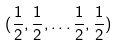<formula> <loc_0><loc_0><loc_500><loc_500>( \frac { 1 } { 2 } , \frac { 1 } { 2 } , \dots \frac { 1 } { 2 } , \frac { 1 } { 2 } )</formula> 